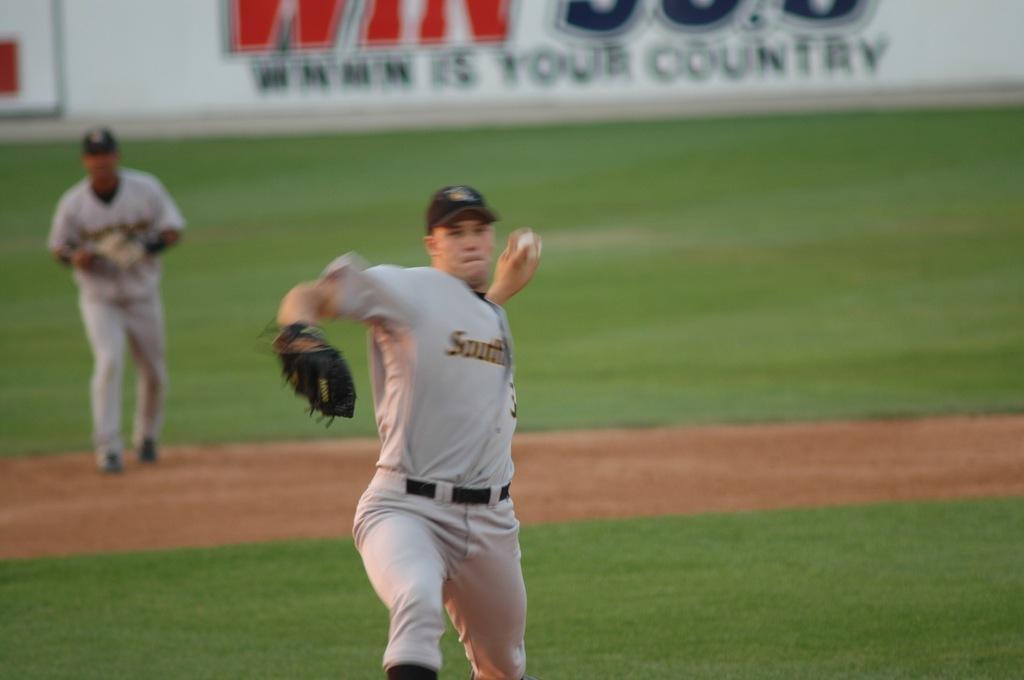Can you describe this image briefly? In this image we can see two persons are playing baseball, one of them is throwing a ball, there is a board with text on it. 